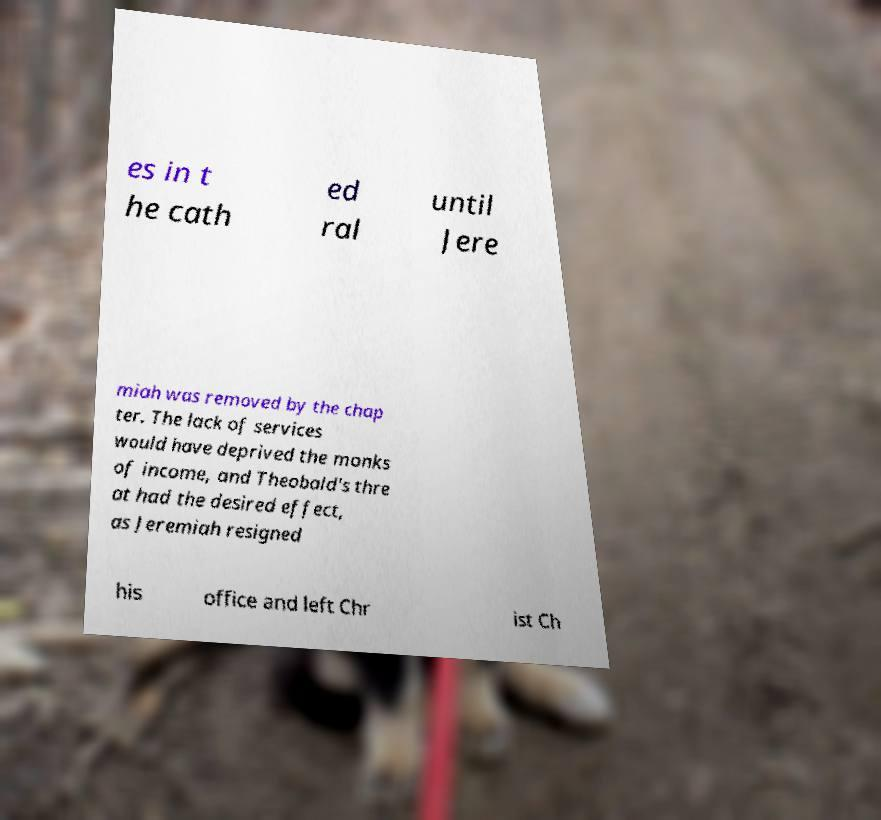There's text embedded in this image that I need extracted. Can you transcribe it verbatim? es in t he cath ed ral until Jere miah was removed by the chap ter. The lack of services would have deprived the monks of income, and Theobald's thre at had the desired effect, as Jeremiah resigned his office and left Chr ist Ch 